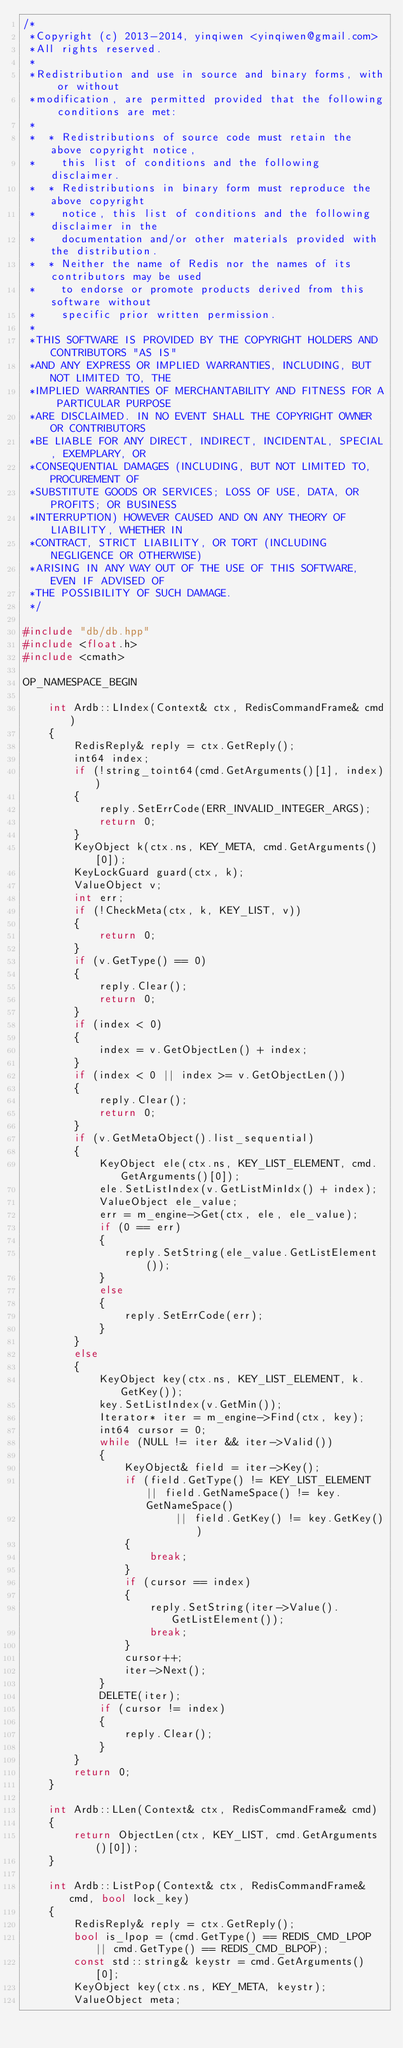<code> <loc_0><loc_0><loc_500><loc_500><_C++_>/*
 *Copyright (c) 2013-2014, yinqiwen <yinqiwen@gmail.com>
 *All rights reserved.
 *
 *Redistribution and use in source and binary forms, with or without
 *modification, are permitted provided that the following conditions are met:
 *
 *  * Redistributions of source code must retain the above copyright notice,
 *    this list of conditions and the following disclaimer.
 *  * Redistributions in binary form must reproduce the above copyright
 *    notice, this list of conditions and the following disclaimer in the
 *    documentation and/or other materials provided with the distribution.
 *  * Neither the name of Redis nor the names of its contributors may be used
 *    to endorse or promote products derived from this software without
 *    specific prior written permission.
 *
 *THIS SOFTWARE IS PROVIDED BY THE COPYRIGHT HOLDERS AND CONTRIBUTORS "AS IS"
 *AND ANY EXPRESS OR IMPLIED WARRANTIES, INCLUDING, BUT NOT LIMITED TO, THE
 *IMPLIED WARRANTIES OF MERCHANTABILITY AND FITNESS FOR A PARTICULAR PURPOSE
 *ARE DISCLAIMED. IN NO EVENT SHALL THE COPYRIGHT OWNER OR CONTRIBUTORS
 *BE LIABLE FOR ANY DIRECT, INDIRECT, INCIDENTAL, SPECIAL, EXEMPLARY, OR
 *CONSEQUENTIAL DAMAGES (INCLUDING, BUT NOT LIMITED TO, PROCUREMENT OF
 *SUBSTITUTE GOODS OR SERVICES; LOSS OF USE, DATA, OR PROFITS; OR BUSINESS
 *INTERRUPTION) HOWEVER CAUSED AND ON ANY THEORY OF LIABILITY, WHETHER IN
 *CONTRACT, STRICT LIABILITY, OR TORT (INCLUDING NEGLIGENCE OR OTHERWISE)
 *ARISING IN ANY WAY OUT OF THE USE OF THIS SOFTWARE, EVEN IF ADVISED OF
 *THE POSSIBILITY OF SUCH DAMAGE.
 */

#include "db/db.hpp"
#include <float.h>
#include <cmath>

OP_NAMESPACE_BEGIN

    int Ardb::LIndex(Context& ctx, RedisCommandFrame& cmd)
    {
        RedisReply& reply = ctx.GetReply();
        int64 index;
        if (!string_toint64(cmd.GetArguments()[1], index))
        {
            reply.SetErrCode(ERR_INVALID_INTEGER_ARGS);
            return 0;
        }
        KeyObject k(ctx.ns, KEY_META, cmd.GetArguments()[0]);
        KeyLockGuard guard(ctx, k);
        ValueObject v;
        int err;
        if (!CheckMeta(ctx, k, KEY_LIST, v))
        {
            return 0;
        }
        if (v.GetType() == 0)
        {
            reply.Clear();
            return 0;
        }
        if (index < 0)
        {
            index = v.GetObjectLen() + index;
        }
        if (index < 0 || index >= v.GetObjectLen())
        {
            reply.Clear();
            return 0;
        }
        if (v.GetMetaObject().list_sequential)
        {
            KeyObject ele(ctx.ns, KEY_LIST_ELEMENT, cmd.GetArguments()[0]);
            ele.SetListIndex(v.GetListMinIdx() + index);
            ValueObject ele_value;
            err = m_engine->Get(ctx, ele, ele_value);
            if (0 == err)
            {
                reply.SetString(ele_value.GetListElement());
            }
            else
            {
                reply.SetErrCode(err);
            }
        }
        else
        {
            KeyObject key(ctx.ns, KEY_LIST_ELEMENT, k.GetKey());
            key.SetListIndex(v.GetMin());
            Iterator* iter = m_engine->Find(ctx, key);
            int64 cursor = 0;
            while (NULL != iter && iter->Valid())
            {
                KeyObject& field = iter->Key();
                if (field.GetType() != KEY_LIST_ELEMENT || field.GetNameSpace() != key.GetNameSpace()
                        || field.GetKey() != key.GetKey())
                {
                    break;
                }
                if (cursor == index)
                {
                    reply.SetString(iter->Value().GetListElement());
                    break;
                }
                cursor++;
                iter->Next();
            }
            DELETE(iter);
            if (cursor != index)
            {
                reply.Clear();
            }
        }
        return 0;
    }

    int Ardb::LLen(Context& ctx, RedisCommandFrame& cmd)
    {
        return ObjectLen(ctx, KEY_LIST, cmd.GetArguments()[0]);
    }

    int Ardb::ListPop(Context& ctx, RedisCommandFrame& cmd, bool lock_key)
    {
        RedisReply& reply = ctx.GetReply();
        bool is_lpop = (cmd.GetType() == REDIS_CMD_LPOP || cmd.GetType() == REDIS_CMD_BLPOP);
        const std::string& keystr = cmd.GetArguments()[0];
        KeyObject key(ctx.ns, KEY_META, keystr);
        ValueObject meta;</code> 